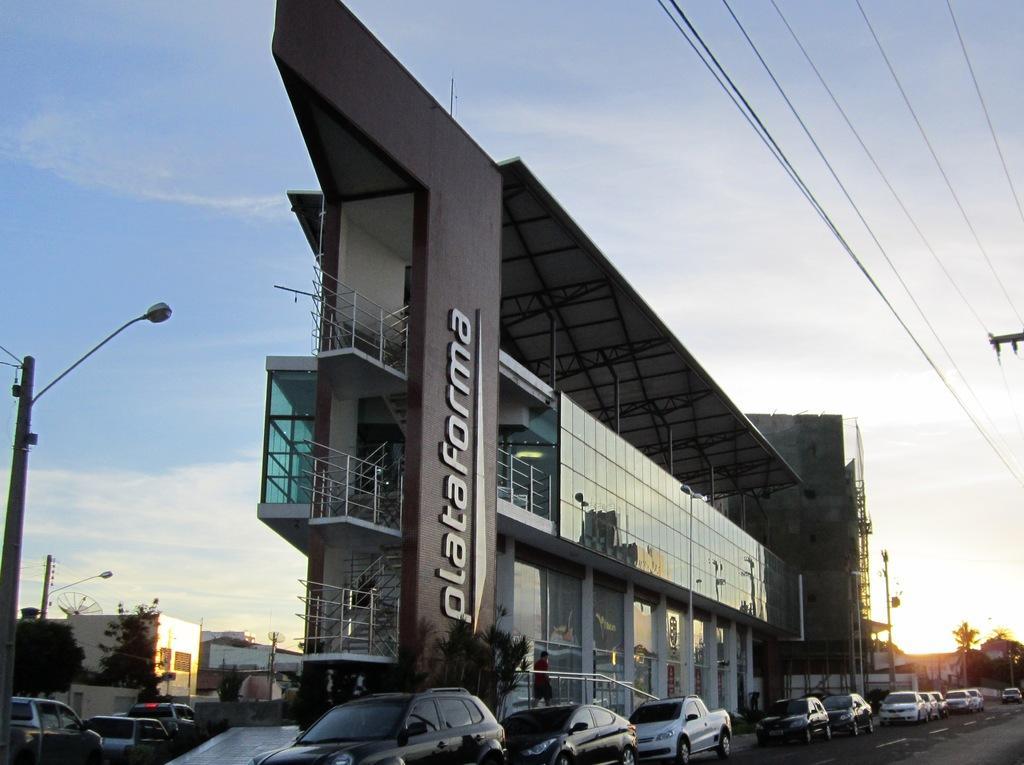Could you give a brief overview of what you see in this image? In the foreground of this image, there are vehicles at the bottom on the road. In the middle, there is a building and a pole on the left. In the background, there are trees, buildings and few vehicles. At the top, there are cables and the sky. 